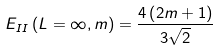Convert formula to latex. <formula><loc_0><loc_0><loc_500><loc_500>E _ { I I } \left ( L = \infty , m \right ) = \frac { 4 \left ( 2 m + 1 \right ) } { 3 \sqrt { 2 } }</formula> 